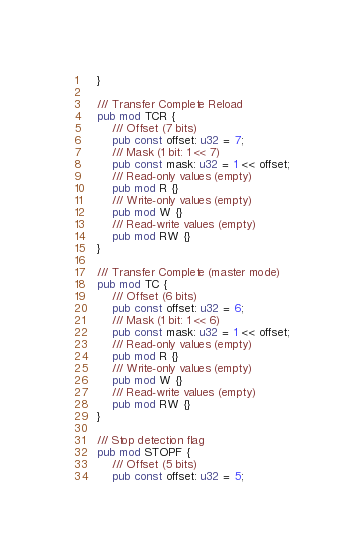Convert code to text. <code><loc_0><loc_0><loc_500><loc_500><_Rust_>    }

    /// Transfer Complete Reload
    pub mod TCR {
        /// Offset (7 bits)
        pub const offset: u32 = 7;
        /// Mask (1 bit: 1 << 7)
        pub const mask: u32 = 1 << offset;
        /// Read-only values (empty)
        pub mod R {}
        /// Write-only values (empty)
        pub mod W {}
        /// Read-write values (empty)
        pub mod RW {}
    }

    /// Transfer Complete (master mode)
    pub mod TC {
        /// Offset (6 bits)
        pub const offset: u32 = 6;
        /// Mask (1 bit: 1 << 6)
        pub const mask: u32 = 1 << offset;
        /// Read-only values (empty)
        pub mod R {}
        /// Write-only values (empty)
        pub mod W {}
        /// Read-write values (empty)
        pub mod RW {}
    }

    /// Stop detection flag
    pub mod STOPF {
        /// Offset (5 bits)
        pub const offset: u32 = 5;</code> 